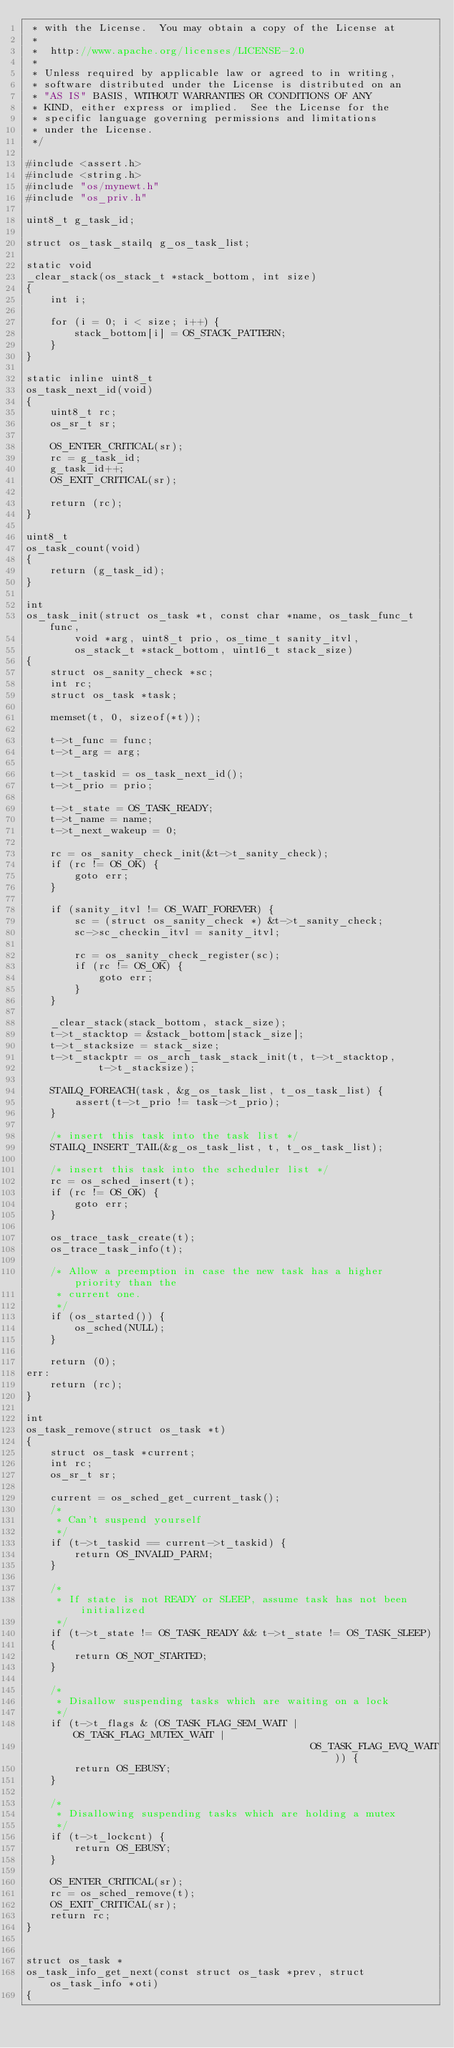<code> <loc_0><loc_0><loc_500><loc_500><_C_> * with the License.  You may obtain a copy of the License at
 *
 *  http://www.apache.org/licenses/LICENSE-2.0
 *
 * Unless required by applicable law or agreed to in writing,
 * software distributed under the License is distributed on an
 * "AS IS" BASIS, WITHOUT WARRANTIES OR CONDITIONS OF ANY
 * KIND, either express or implied.  See the License for the
 * specific language governing permissions and limitations
 * under the License.
 */

#include <assert.h>
#include <string.h>
#include "os/mynewt.h"
#include "os_priv.h"

uint8_t g_task_id;

struct os_task_stailq g_os_task_list;

static void
_clear_stack(os_stack_t *stack_bottom, int size)
{
    int i;

    for (i = 0; i < size; i++) {
        stack_bottom[i] = OS_STACK_PATTERN;
    }
}

static inline uint8_t
os_task_next_id(void)
{
    uint8_t rc;
    os_sr_t sr;

    OS_ENTER_CRITICAL(sr);
    rc = g_task_id;
    g_task_id++;
    OS_EXIT_CRITICAL(sr);

    return (rc);
}

uint8_t
os_task_count(void)
{
    return (g_task_id);
}

int
os_task_init(struct os_task *t, const char *name, os_task_func_t func,
        void *arg, uint8_t prio, os_time_t sanity_itvl,
        os_stack_t *stack_bottom, uint16_t stack_size)
{
    struct os_sanity_check *sc;
    int rc;
    struct os_task *task;

    memset(t, 0, sizeof(*t));

    t->t_func = func;
    t->t_arg = arg;

    t->t_taskid = os_task_next_id();
    t->t_prio = prio;

    t->t_state = OS_TASK_READY;
    t->t_name = name;
    t->t_next_wakeup = 0;

    rc = os_sanity_check_init(&t->t_sanity_check);
    if (rc != OS_OK) {
        goto err;
    }

    if (sanity_itvl != OS_WAIT_FOREVER) {
        sc = (struct os_sanity_check *) &t->t_sanity_check;
        sc->sc_checkin_itvl = sanity_itvl;

        rc = os_sanity_check_register(sc);
        if (rc != OS_OK) {
            goto err;
        }
    }

    _clear_stack(stack_bottom, stack_size);
    t->t_stacktop = &stack_bottom[stack_size];
    t->t_stacksize = stack_size;
    t->t_stackptr = os_arch_task_stack_init(t, t->t_stacktop,
            t->t_stacksize);

    STAILQ_FOREACH(task, &g_os_task_list, t_os_task_list) {
        assert(t->t_prio != task->t_prio);
    }

    /* insert this task into the task list */
    STAILQ_INSERT_TAIL(&g_os_task_list, t, t_os_task_list);

    /* insert this task into the scheduler list */
    rc = os_sched_insert(t);
    if (rc != OS_OK) {
        goto err;
    }

    os_trace_task_create(t);
    os_trace_task_info(t);

    /* Allow a preemption in case the new task has a higher priority than the
     * current one.
     */
    if (os_started()) {
        os_sched(NULL);
    }

    return (0);
err:
    return (rc);
}

int
os_task_remove(struct os_task *t)
{
    struct os_task *current;
    int rc;
    os_sr_t sr;

    current = os_sched_get_current_task();
    /*
     * Can't suspend yourself
     */
    if (t->t_taskid == current->t_taskid) {
        return OS_INVALID_PARM;
    }

    /*
     * If state is not READY or SLEEP, assume task has not been initialized
     */
    if (t->t_state != OS_TASK_READY && t->t_state != OS_TASK_SLEEP)
    {
        return OS_NOT_STARTED;
    }

    /*
     * Disallow suspending tasks which are waiting on a lock
     */
    if (t->t_flags & (OS_TASK_FLAG_SEM_WAIT | OS_TASK_FLAG_MUTEX_WAIT |
                                               OS_TASK_FLAG_EVQ_WAIT)) {
        return OS_EBUSY;
    }

    /*
     * Disallowing suspending tasks which are holding a mutex
     */
    if (t->t_lockcnt) {
        return OS_EBUSY;
    }

    OS_ENTER_CRITICAL(sr);
    rc = os_sched_remove(t);
    OS_EXIT_CRITICAL(sr);
    return rc;
}


struct os_task *
os_task_info_get_next(const struct os_task *prev, struct os_task_info *oti)
{</code> 